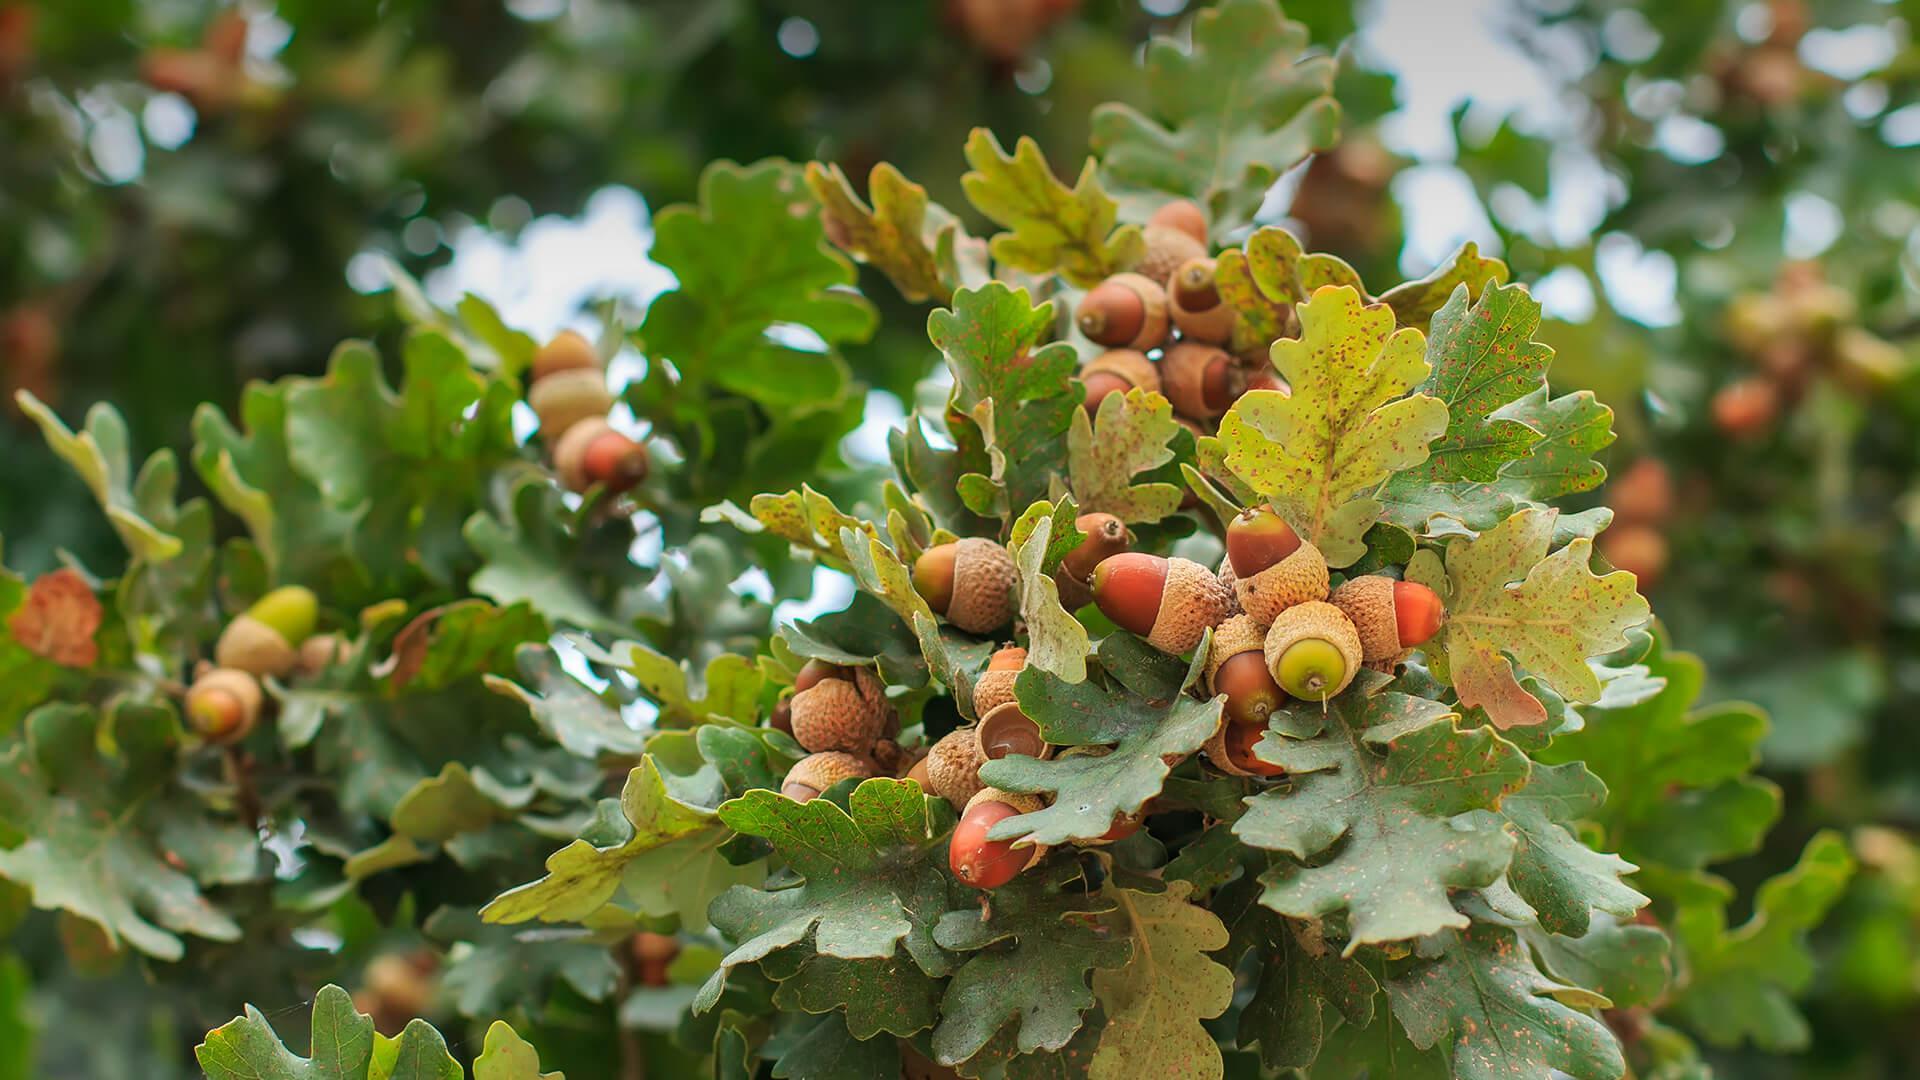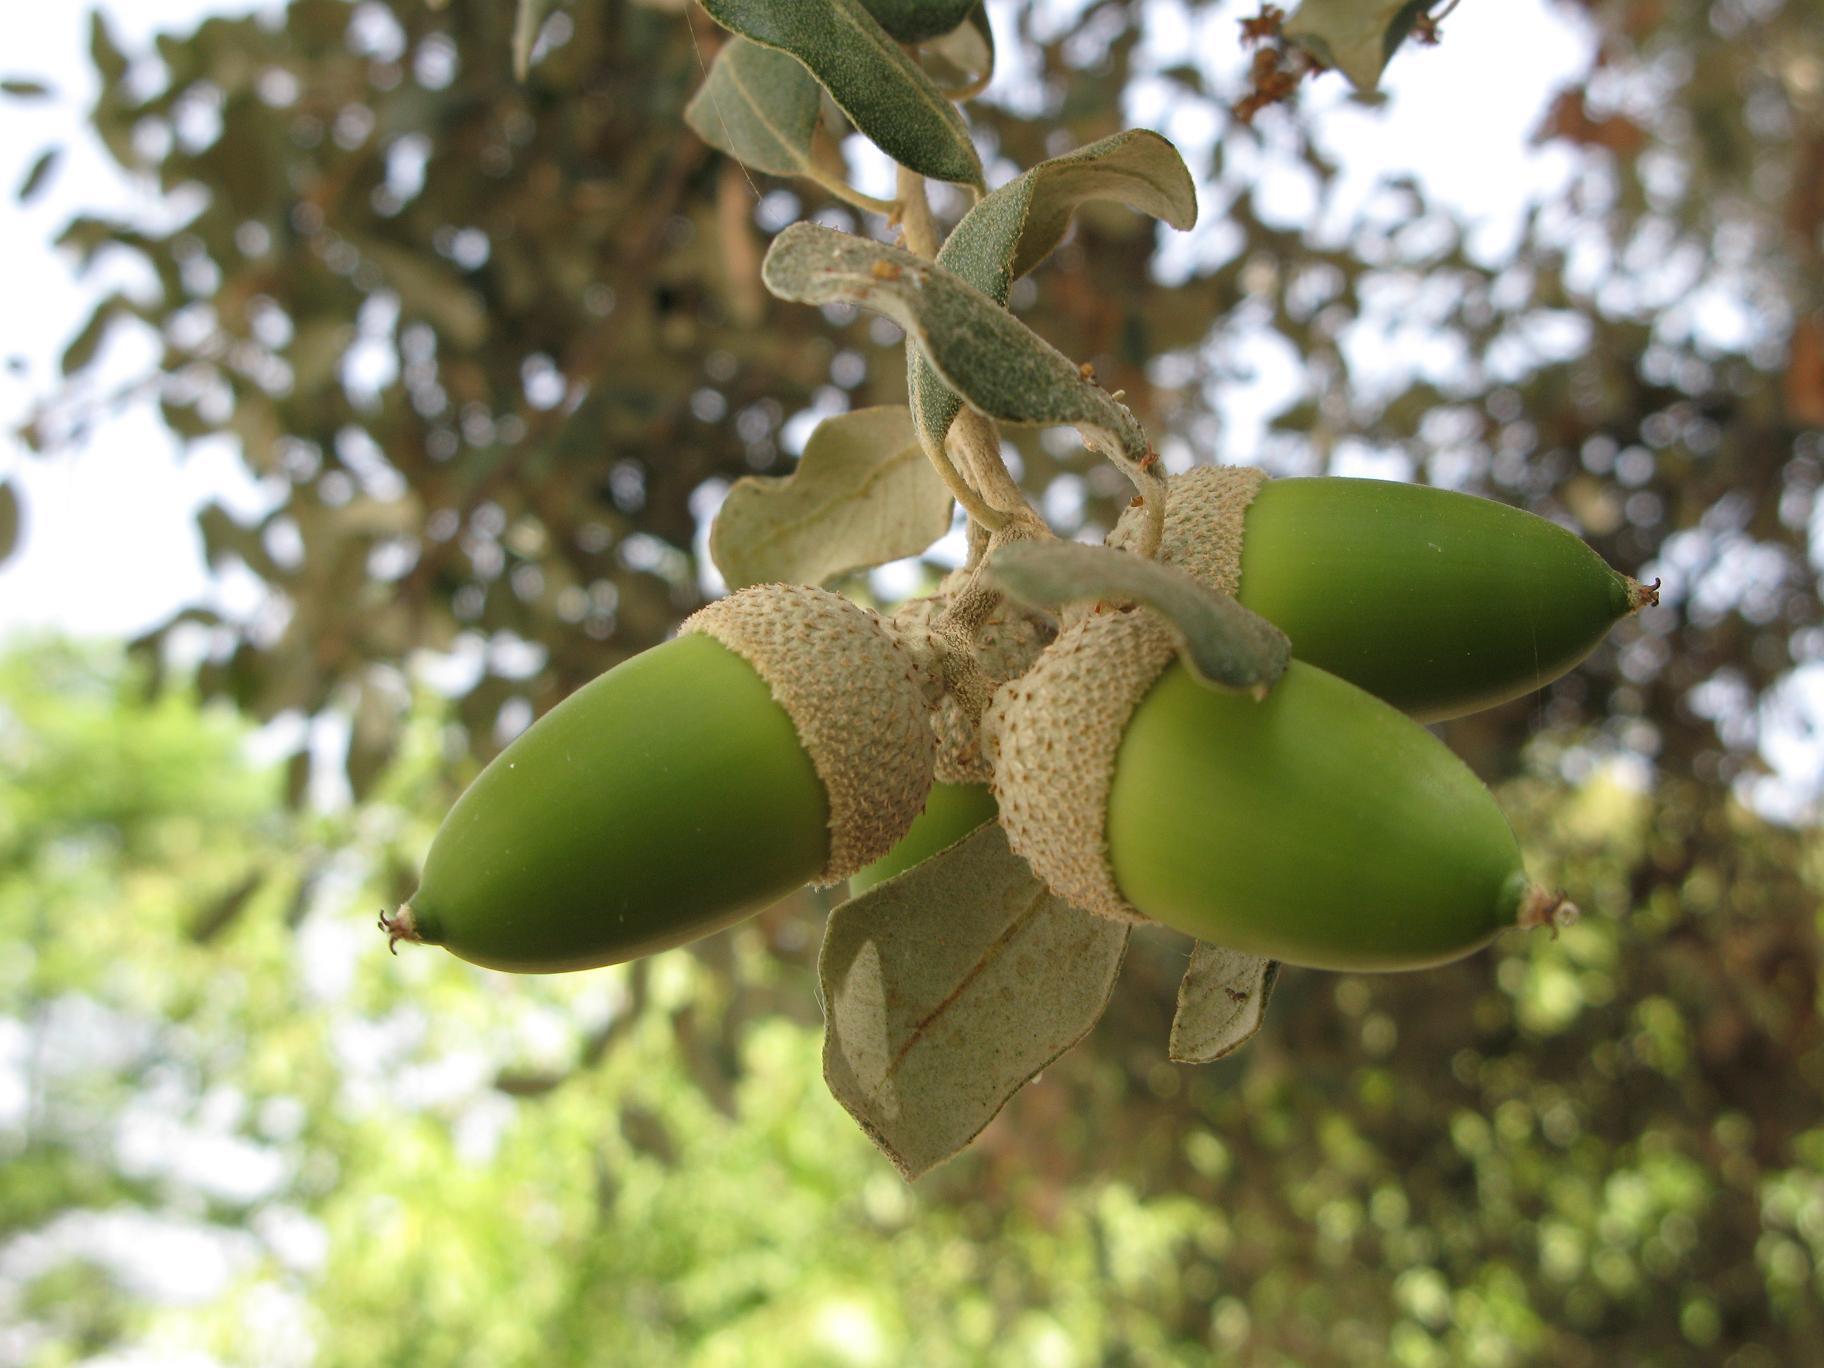The first image is the image on the left, the second image is the image on the right. Given the left and right images, does the statement "The left image contains only acorns that are green, and the right image contains only acorns that are brown." hold true? Answer yes or no. No. The first image is the image on the left, the second image is the image on the right. For the images displayed, is the sentence "One image shows a single acorn attached to an oak tree." factually correct? Answer yes or no. No. 